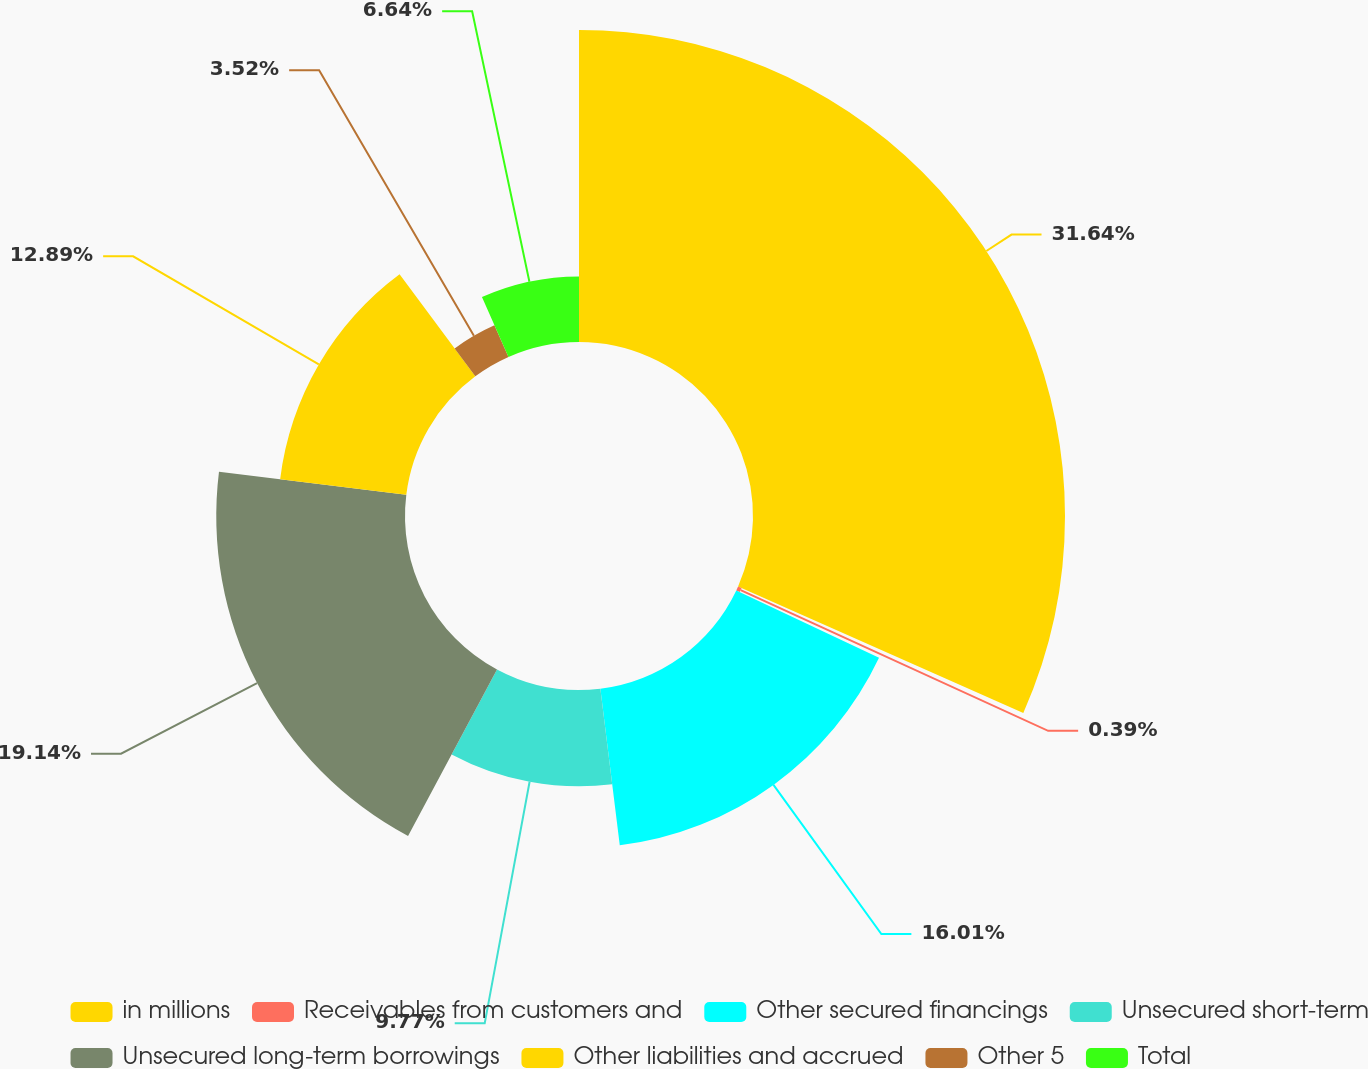Convert chart to OTSL. <chart><loc_0><loc_0><loc_500><loc_500><pie_chart><fcel>in millions<fcel>Receivables from customers and<fcel>Other secured financings<fcel>Unsecured short-term<fcel>Unsecured long-term borrowings<fcel>Other liabilities and accrued<fcel>Other 5<fcel>Total<nl><fcel>31.64%<fcel>0.39%<fcel>16.01%<fcel>9.77%<fcel>19.14%<fcel>12.89%<fcel>3.52%<fcel>6.64%<nl></chart> 